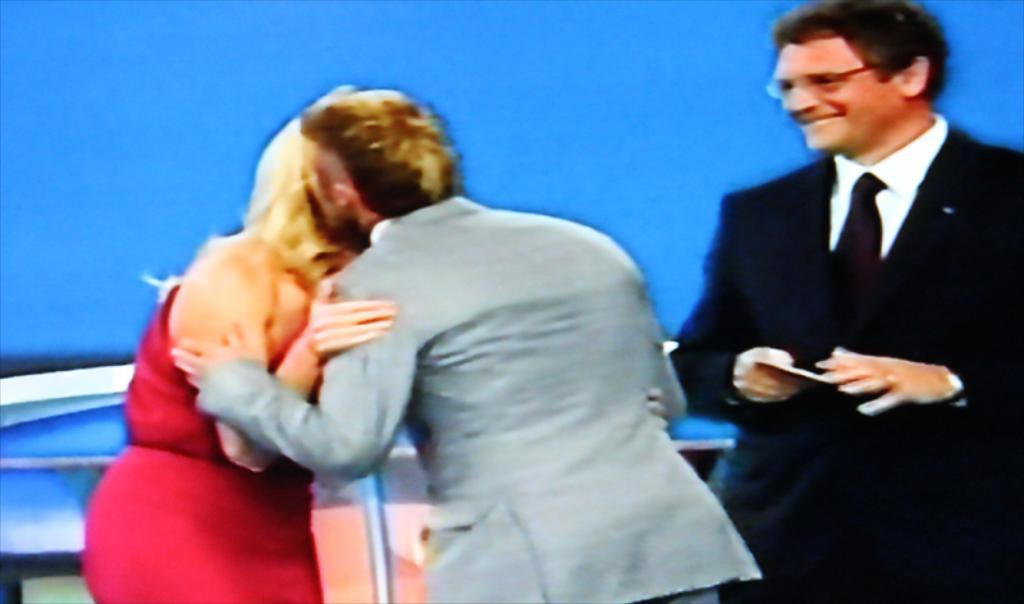What are the two people in the foreground doing? The two people in the foreground are hugging each other. Can you describe the man on the right side of the image? The man is standing on the right side of the image and is smiling. What color is the background of the image? The background of the image is in blue color. What sound does the dad make when he kicks the ball in the image? There is no dad or ball present in the image, so it is not possible to answer that question. 